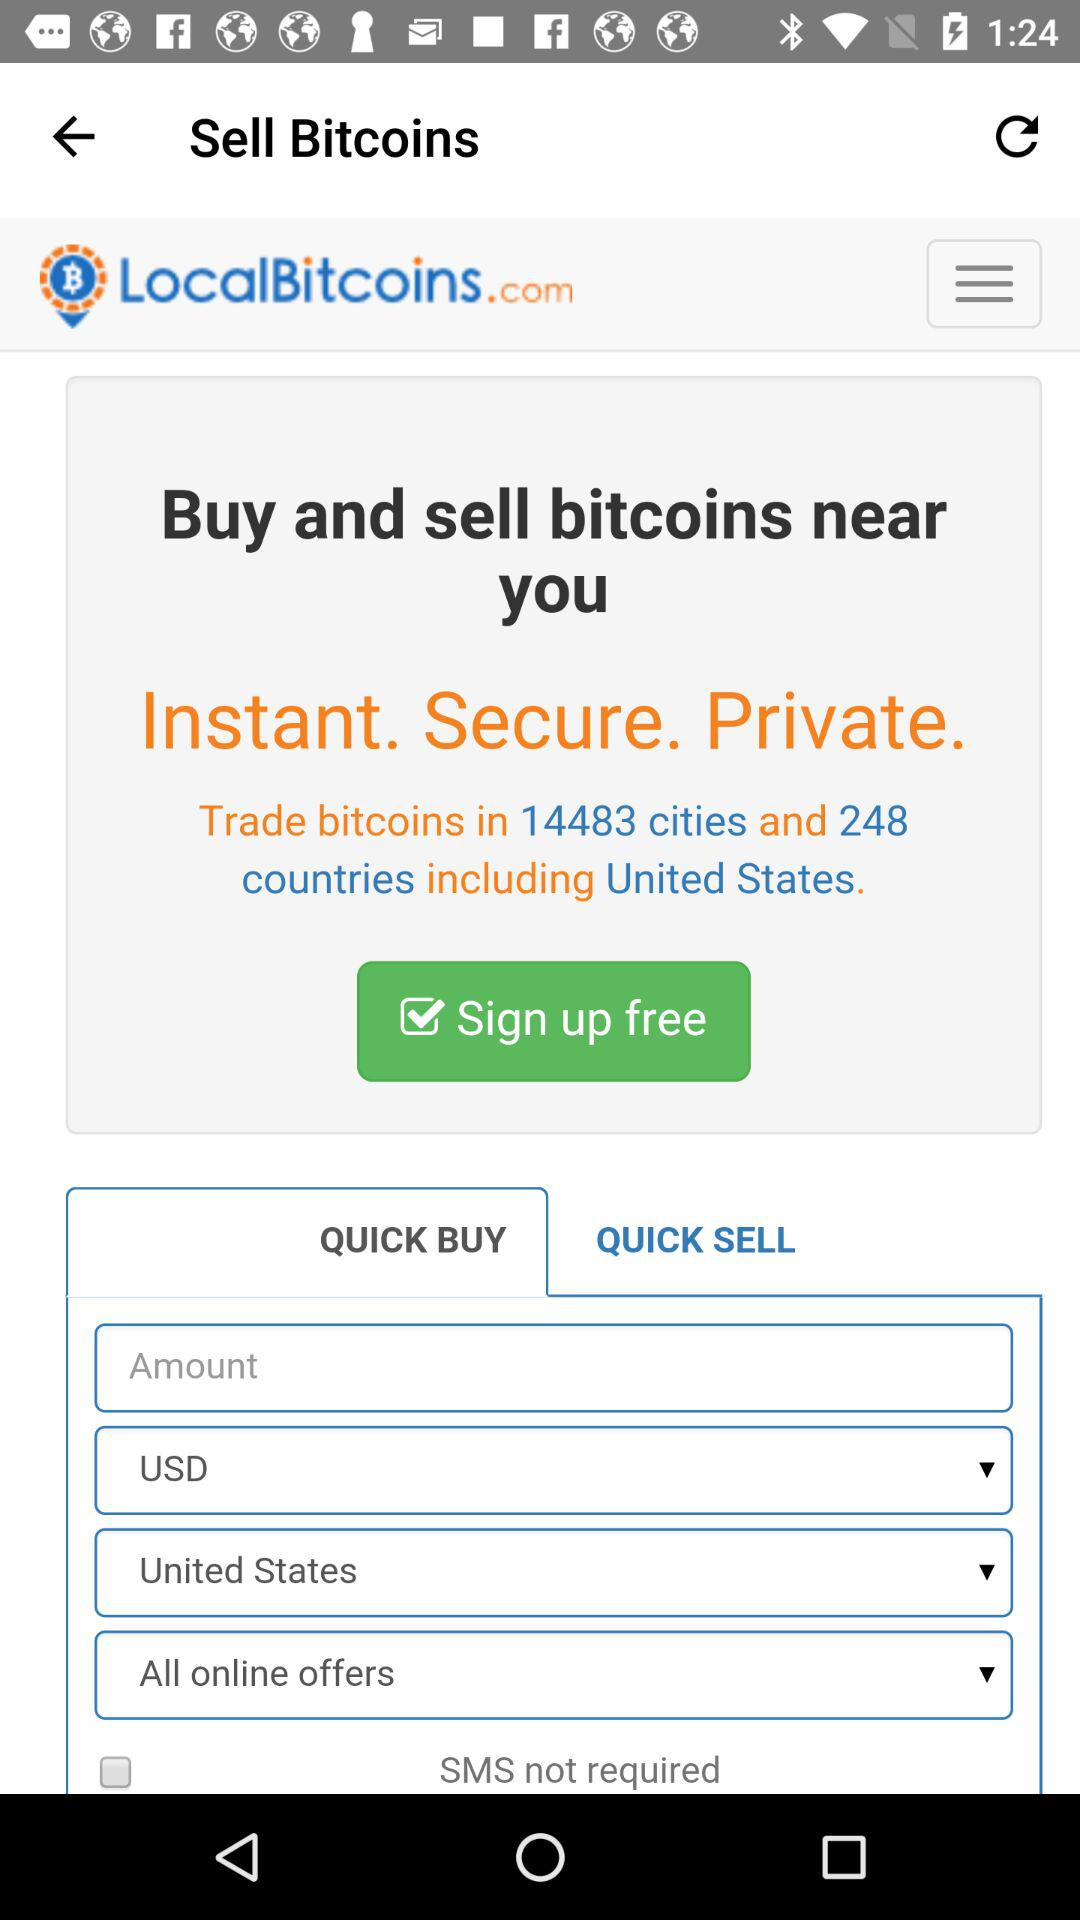How much is the amount?
When the provided information is insufficient, respond with <no answer>. <no answer> 